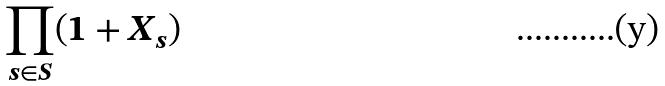<formula> <loc_0><loc_0><loc_500><loc_500>\prod _ { s \in S } ( 1 + X _ { s } )</formula> 